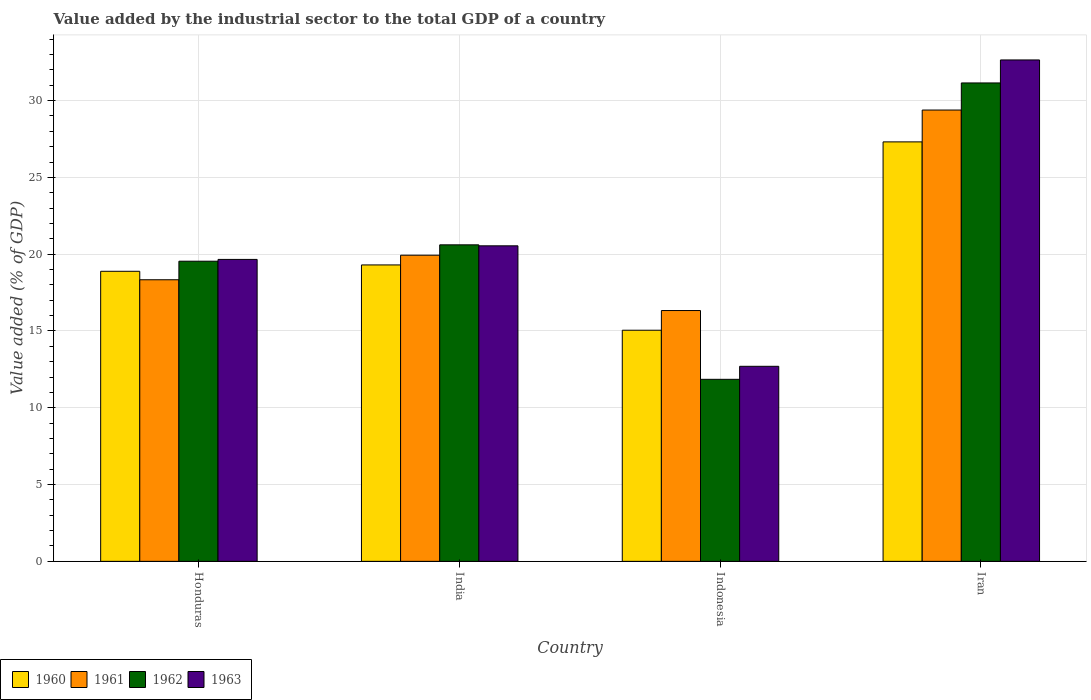Are the number of bars on each tick of the X-axis equal?
Your response must be concise. Yes. How many bars are there on the 1st tick from the right?
Provide a succinct answer. 4. What is the value added by the industrial sector to the total GDP in 1962 in Honduras?
Your answer should be very brief. 19.54. Across all countries, what is the maximum value added by the industrial sector to the total GDP in 1960?
Give a very brief answer. 27.31. Across all countries, what is the minimum value added by the industrial sector to the total GDP in 1963?
Provide a succinct answer. 12.7. In which country was the value added by the industrial sector to the total GDP in 1961 maximum?
Your answer should be very brief. Iran. What is the total value added by the industrial sector to the total GDP in 1962 in the graph?
Your response must be concise. 83.15. What is the difference between the value added by the industrial sector to the total GDP in 1960 in Honduras and that in Indonesia?
Offer a terse response. 3.84. What is the difference between the value added by the industrial sector to the total GDP in 1961 in Iran and the value added by the industrial sector to the total GDP in 1963 in Indonesia?
Keep it short and to the point. 16.69. What is the average value added by the industrial sector to the total GDP in 1960 per country?
Your answer should be very brief. 20.14. What is the difference between the value added by the industrial sector to the total GDP of/in 1962 and value added by the industrial sector to the total GDP of/in 1960 in Iran?
Your response must be concise. 3.84. In how many countries, is the value added by the industrial sector to the total GDP in 1961 greater than 33 %?
Make the answer very short. 0. What is the ratio of the value added by the industrial sector to the total GDP in 1961 in Honduras to that in Iran?
Make the answer very short. 0.62. Is the difference between the value added by the industrial sector to the total GDP in 1962 in Honduras and Iran greater than the difference between the value added by the industrial sector to the total GDP in 1960 in Honduras and Iran?
Provide a succinct answer. No. What is the difference between the highest and the second highest value added by the industrial sector to the total GDP in 1960?
Provide a short and direct response. 0.41. What is the difference between the highest and the lowest value added by the industrial sector to the total GDP in 1963?
Offer a terse response. 19.95. In how many countries, is the value added by the industrial sector to the total GDP in 1963 greater than the average value added by the industrial sector to the total GDP in 1963 taken over all countries?
Provide a succinct answer. 1. What does the 3rd bar from the left in Iran represents?
Offer a very short reply. 1962. What does the 3rd bar from the right in Indonesia represents?
Offer a terse response. 1961. Is it the case that in every country, the sum of the value added by the industrial sector to the total GDP in 1962 and value added by the industrial sector to the total GDP in 1960 is greater than the value added by the industrial sector to the total GDP in 1961?
Your response must be concise. Yes. How many bars are there?
Keep it short and to the point. 16. Are all the bars in the graph horizontal?
Provide a succinct answer. No. What is the difference between two consecutive major ticks on the Y-axis?
Give a very brief answer. 5. Does the graph contain any zero values?
Offer a terse response. No. Where does the legend appear in the graph?
Your answer should be compact. Bottom left. How many legend labels are there?
Make the answer very short. 4. What is the title of the graph?
Give a very brief answer. Value added by the industrial sector to the total GDP of a country. Does "1990" appear as one of the legend labels in the graph?
Provide a short and direct response. No. What is the label or title of the X-axis?
Your answer should be very brief. Country. What is the label or title of the Y-axis?
Your response must be concise. Value added (% of GDP). What is the Value added (% of GDP) of 1960 in Honduras?
Keep it short and to the point. 18.89. What is the Value added (% of GDP) in 1961 in Honduras?
Offer a very short reply. 18.33. What is the Value added (% of GDP) in 1962 in Honduras?
Your answer should be compact. 19.54. What is the Value added (% of GDP) in 1963 in Honduras?
Offer a very short reply. 19.66. What is the Value added (% of GDP) in 1960 in India?
Keep it short and to the point. 19.3. What is the Value added (% of GDP) of 1961 in India?
Provide a succinct answer. 19.93. What is the Value added (% of GDP) in 1962 in India?
Offer a very short reply. 20.61. What is the Value added (% of GDP) in 1963 in India?
Provide a short and direct response. 20.54. What is the Value added (% of GDP) in 1960 in Indonesia?
Give a very brief answer. 15.05. What is the Value added (% of GDP) of 1961 in Indonesia?
Provide a succinct answer. 16.33. What is the Value added (% of GDP) in 1962 in Indonesia?
Offer a terse response. 11.85. What is the Value added (% of GDP) of 1963 in Indonesia?
Offer a very short reply. 12.7. What is the Value added (% of GDP) of 1960 in Iran?
Provide a short and direct response. 27.31. What is the Value added (% of GDP) of 1961 in Iran?
Your response must be concise. 29.38. What is the Value added (% of GDP) of 1962 in Iran?
Keep it short and to the point. 31.15. What is the Value added (% of GDP) of 1963 in Iran?
Keep it short and to the point. 32.65. Across all countries, what is the maximum Value added (% of GDP) in 1960?
Offer a terse response. 27.31. Across all countries, what is the maximum Value added (% of GDP) of 1961?
Your answer should be compact. 29.38. Across all countries, what is the maximum Value added (% of GDP) of 1962?
Your answer should be very brief. 31.15. Across all countries, what is the maximum Value added (% of GDP) of 1963?
Your answer should be very brief. 32.65. Across all countries, what is the minimum Value added (% of GDP) of 1960?
Provide a short and direct response. 15.05. Across all countries, what is the minimum Value added (% of GDP) of 1961?
Provide a short and direct response. 16.33. Across all countries, what is the minimum Value added (% of GDP) of 1962?
Offer a very short reply. 11.85. Across all countries, what is the minimum Value added (% of GDP) of 1963?
Your answer should be very brief. 12.7. What is the total Value added (% of GDP) in 1960 in the graph?
Your answer should be very brief. 80.55. What is the total Value added (% of GDP) in 1961 in the graph?
Ensure brevity in your answer.  83.98. What is the total Value added (% of GDP) in 1962 in the graph?
Give a very brief answer. 83.15. What is the total Value added (% of GDP) in 1963 in the graph?
Your answer should be compact. 85.55. What is the difference between the Value added (% of GDP) of 1960 in Honduras and that in India?
Your answer should be very brief. -0.41. What is the difference between the Value added (% of GDP) in 1961 in Honduras and that in India?
Your answer should be very brief. -1.6. What is the difference between the Value added (% of GDP) of 1962 in Honduras and that in India?
Your answer should be compact. -1.07. What is the difference between the Value added (% of GDP) in 1963 in Honduras and that in India?
Give a very brief answer. -0.88. What is the difference between the Value added (% of GDP) in 1960 in Honduras and that in Indonesia?
Ensure brevity in your answer.  3.84. What is the difference between the Value added (% of GDP) in 1961 in Honduras and that in Indonesia?
Make the answer very short. 2. What is the difference between the Value added (% of GDP) of 1962 in Honduras and that in Indonesia?
Make the answer very short. 7.69. What is the difference between the Value added (% of GDP) of 1963 in Honduras and that in Indonesia?
Provide a short and direct response. 6.96. What is the difference between the Value added (% of GDP) of 1960 in Honduras and that in Iran?
Give a very brief answer. -8.43. What is the difference between the Value added (% of GDP) of 1961 in Honduras and that in Iran?
Keep it short and to the point. -11.05. What is the difference between the Value added (% of GDP) of 1962 in Honduras and that in Iran?
Your response must be concise. -11.61. What is the difference between the Value added (% of GDP) of 1963 in Honduras and that in Iran?
Give a very brief answer. -12.99. What is the difference between the Value added (% of GDP) of 1960 in India and that in Indonesia?
Your answer should be compact. 4.25. What is the difference between the Value added (% of GDP) in 1961 in India and that in Indonesia?
Your answer should be very brief. 3.6. What is the difference between the Value added (% of GDP) in 1962 in India and that in Indonesia?
Offer a terse response. 8.76. What is the difference between the Value added (% of GDP) of 1963 in India and that in Indonesia?
Your response must be concise. 7.84. What is the difference between the Value added (% of GDP) of 1960 in India and that in Iran?
Your response must be concise. -8.01. What is the difference between the Value added (% of GDP) of 1961 in India and that in Iran?
Your response must be concise. -9.45. What is the difference between the Value added (% of GDP) of 1962 in India and that in Iran?
Offer a terse response. -10.54. What is the difference between the Value added (% of GDP) of 1963 in India and that in Iran?
Your response must be concise. -12.1. What is the difference between the Value added (% of GDP) of 1960 in Indonesia and that in Iran?
Make the answer very short. -12.26. What is the difference between the Value added (% of GDP) in 1961 in Indonesia and that in Iran?
Provide a short and direct response. -13.05. What is the difference between the Value added (% of GDP) in 1962 in Indonesia and that in Iran?
Your answer should be very brief. -19.3. What is the difference between the Value added (% of GDP) in 1963 in Indonesia and that in Iran?
Your response must be concise. -19.95. What is the difference between the Value added (% of GDP) in 1960 in Honduras and the Value added (% of GDP) in 1961 in India?
Offer a terse response. -1.05. What is the difference between the Value added (% of GDP) of 1960 in Honduras and the Value added (% of GDP) of 1962 in India?
Provide a short and direct response. -1.72. What is the difference between the Value added (% of GDP) of 1960 in Honduras and the Value added (% of GDP) of 1963 in India?
Ensure brevity in your answer.  -1.66. What is the difference between the Value added (% of GDP) of 1961 in Honduras and the Value added (% of GDP) of 1962 in India?
Ensure brevity in your answer.  -2.27. What is the difference between the Value added (% of GDP) in 1961 in Honduras and the Value added (% of GDP) in 1963 in India?
Make the answer very short. -2.21. What is the difference between the Value added (% of GDP) of 1962 in Honduras and the Value added (% of GDP) of 1963 in India?
Provide a succinct answer. -1. What is the difference between the Value added (% of GDP) of 1960 in Honduras and the Value added (% of GDP) of 1961 in Indonesia?
Give a very brief answer. 2.56. What is the difference between the Value added (% of GDP) in 1960 in Honduras and the Value added (% of GDP) in 1962 in Indonesia?
Your response must be concise. 7.03. What is the difference between the Value added (% of GDP) of 1960 in Honduras and the Value added (% of GDP) of 1963 in Indonesia?
Provide a succinct answer. 6.19. What is the difference between the Value added (% of GDP) of 1961 in Honduras and the Value added (% of GDP) of 1962 in Indonesia?
Provide a short and direct response. 6.48. What is the difference between the Value added (% of GDP) in 1961 in Honduras and the Value added (% of GDP) in 1963 in Indonesia?
Offer a terse response. 5.64. What is the difference between the Value added (% of GDP) in 1962 in Honduras and the Value added (% of GDP) in 1963 in Indonesia?
Ensure brevity in your answer.  6.84. What is the difference between the Value added (% of GDP) in 1960 in Honduras and the Value added (% of GDP) in 1961 in Iran?
Make the answer very short. -10.5. What is the difference between the Value added (% of GDP) of 1960 in Honduras and the Value added (% of GDP) of 1962 in Iran?
Your response must be concise. -12.26. What is the difference between the Value added (% of GDP) in 1960 in Honduras and the Value added (% of GDP) in 1963 in Iran?
Your response must be concise. -13.76. What is the difference between the Value added (% of GDP) in 1961 in Honduras and the Value added (% of GDP) in 1962 in Iran?
Give a very brief answer. -12.81. What is the difference between the Value added (% of GDP) of 1961 in Honduras and the Value added (% of GDP) of 1963 in Iran?
Give a very brief answer. -14.31. What is the difference between the Value added (% of GDP) in 1962 in Honduras and the Value added (% of GDP) in 1963 in Iran?
Your answer should be compact. -13.1. What is the difference between the Value added (% of GDP) in 1960 in India and the Value added (% of GDP) in 1961 in Indonesia?
Your response must be concise. 2.97. What is the difference between the Value added (% of GDP) in 1960 in India and the Value added (% of GDP) in 1962 in Indonesia?
Offer a very short reply. 7.45. What is the difference between the Value added (% of GDP) in 1960 in India and the Value added (% of GDP) in 1963 in Indonesia?
Keep it short and to the point. 6.6. What is the difference between the Value added (% of GDP) in 1961 in India and the Value added (% of GDP) in 1962 in Indonesia?
Your answer should be very brief. 8.08. What is the difference between the Value added (% of GDP) of 1961 in India and the Value added (% of GDP) of 1963 in Indonesia?
Ensure brevity in your answer.  7.23. What is the difference between the Value added (% of GDP) in 1962 in India and the Value added (% of GDP) in 1963 in Indonesia?
Your response must be concise. 7.91. What is the difference between the Value added (% of GDP) of 1960 in India and the Value added (% of GDP) of 1961 in Iran?
Your response must be concise. -10.09. What is the difference between the Value added (% of GDP) of 1960 in India and the Value added (% of GDP) of 1962 in Iran?
Give a very brief answer. -11.85. What is the difference between the Value added (% of GDP) in 1960 in India and the Value added (% of GDP) in 1963 in Iran?
Offer a very short reply. -13.35. What is the difference between the Value added (% of GDP) in 1961 in India and the Value added (% of GDP) in 1962 in Iran?
Your answer should be very brief. -11.22. What is the difference between the Value added (% of GDP) of 1961 in India and the Value added (% of GDP) of 1963 in Iran?
Offer a terse response. -12.71. What is the difference between the Value added (% of GDP) of 1962 in India and the Value added (% of GDP) of 1963 in Iran?
Offer a very short reply. -12.04. What is the difference between the Value added (% of GDP) of 1960 in Indonesia and the Value added (% of GDP) of 1961 in Iran?
Provide a short and direct response. -14.34. What is the difference between the Value added (% of GDP) of 1960 in Indonesia and the Value added (% of GDP) of 1962 in Iran?
Your answer should be very brief. -16.1. What is the difference between the Value added (% of GDP) in 1960 in Indonesia and the Value added (% of GDP) in 1963 in Iran?
Provide a succinct answer. -17.6. What is the difference between the Value added (% of GDP) of 1961 in Indonesia and the Value added (% of GDP) of 1962 in Iran?
Offer a very short reply. -14.82. What is the difference between the Value added (% of GDP) in 1961 in Indonesia and the Value added (% of GDP) in 1963 in Iran?
Your response must be concise. -16.32. What is the difference between the Value added (% of GDP) in 1962 in Indonesia and the Value added (% of GDP) in 1963 in Iran?
Offer a very short reply. -20.79. What is the average Value added (% of GDP) in 1960 per country?
Provide a short and direct response. 20.14. What is the average Value added (% of GDP) of 1961 per country?
Give a very brief answer. 21. What is the average Value added (% of GDP) in 1962 per country?
Make the answer very short. 20.79. What is the average Value added (% of GDP) of 1963 per country?
Your answer should be compact. 21.39. What is the difference between the Value added (% of GDP) of 1960 and Value added (% of GDP) of 1961 in Honduras?
Make the answer very short. 0.55. What is the difference between the Value added (% of GDP) of 1960 and Value added (% of GDP) of 1962 in Honduras?
Your answer should be compact. -0.66. What is the difference between the Value added (% of GDP) of 1960 and Value added (% of GDP) of 1963 in Honduras?
Your response must be concise. -0.77. What is the difference between the Value added (% of GDP) in 1961 and Value added (% of GDP) in 1962 in Honduras?
Your response must be concise. -1.21. What is the difference between the Value added (% of GDP) in 1961 and Value added (% of GDP) in 1963 in Honduras?
Offer a terse response. -1.32. What is the difference between the Value added (% of GDP) of 1962 and Value added (% of GDP) of 1963 in Honduras?
Your answer should be very brief. -0.12. What is the difference between the Value added (% of GDP) of 1960 and Value added (% of GDP) of 1961 in India?
Your response must be concise. -0.63. What is the difference between the Value added (% of GDP) in 1960 and Value added (% of GDP) in 1962 in India?
Provide a short and direct response. -1.31. What is the difference between the Value added (% of GDP) in 1960 and Value added (% of GDP) in 1963 in India?
Your response must be concise. -1.24. What is the difference between the Value added (% of GDP) in 1961 and Value added (% of GDP) in 1962 in India?
Your answer should be very brief. -0.68. What is the difference between the Value added (% of GDP) in 1961 and Value added (% of GDP) in 1963 in India?
Make the answer very short. -0.61. What is the difference between the Value added (% of GDP) of 1962 and Value added (% of GDP) of 1963 in India?
Make the answer very short. 0.06. What is the difference between the Value added (% of GDP) in 1960 and Value added (% of GDP) in 1961 in Indonesia?
Ensure brevity in your answer.  -1.28. What is the difference between the Value added (% of GDP) of 1960 and Value added (% of GDP) of 1962 in Indonesia?
Your answer should be very brief. 3.2. What is the difference between the Value added (% of GDP) of 1960 and Value added (% of GDP) of 1963 in Indonesia?
Your response must be concise. 2.35. What is the difference between the Value added (% of GDP) of 1961 and Value added (% of GDP) of 1962 in Indonesia?
Ensure brevity in your answer.  4.48. What is the difference between the Value added (% of GDP) of 1961 and Value added (% of GDP) of 1963 in Indonesia?
Provide a succinct answer. 3.63. What is the difference between the Value added (% of GDP) of 1962 and Value added (% of GDP) of 1963 in Indonesia?
Your answer should be compact. -0.85. What is the difference between the Value added (% of GDP) of 1960 and Value added (% of GDP) of 1961 in Iran?
Ensure brevity in your answer.  -2.07. What is the difference between the Value added (% of GDP) of 1960 and Value added (% of GDP) of 1962 in Iran?
Offer a very short reply. -3.84. What is the difference between the Value added (% of GDP) in 1960 and Value added (% of GDP) in 1963 in Iran?
Ensure brevity in your answer.  -5.33. What is the difference between the Value added (% of GDP) in 1961 and Value added (% of GDP) in 1962 in Iran?
Your answer should be compact. -1.76. What is the difference between the Value added (% of GDP) in 1961 and Value added (% of GDP) in 1963 in Iran?
Give a very brief answer. -3.26. What is the difference between the Value added (% of GDP) of 1962 and Value added (% of GDP) of 1963 in Iran?
Offer a terse response. -1.5. What is the ratio of the Value added (% of GDP) of 1960 in Honduras to that in India?
Keep it short and to the point. 0.98. What is the ratio of the Value added (% of GDP) of 1961 in Honduras to that in India?
Keep it short and to the point. 0.92. What is the ratio of the Value added (% of GDP) in 1962 in Honduras to that in India?
Provide a short and direct response. 0.95. What is the ratio of the Value added (% of GDP) in 1963 in Honduras to that in India?
Provide a short and direct response. 0.96. What is the ratio of the Value added (% of GDP) of 1960 in Honduras to that in Indonesia?
Ensure brevity in your answer.  1.25. What is the ratio of the Value added (% of GDP) of 1961 in Honduras to that in Indonesia?
Give a very brief answer. 1.12. What is the ratio of the Value added (% of GDP) of 1962 in Honduras to that in Indonesia?
Give a very brief answer. 1.65. What is the ratio of the Value added (% of GDP) in 1963 in Honduras to that in Indonesia?
Provide a short and direct response. 1.55. What is the ratio of the Value added (% of GDP) of 1960 in Honduras to that in Iran?
Your response must be concise. 0.69. What is the ratio of the Value added (% of GDP) of 1961 in Honduras to that in Iran?
Offer a terse response. 0.62. What is the ratio of the Value added (% of GDP) in 1962 in Honduras to that in Iran?
Keep it short and to the point. 0.63. What is the ratio of the Value added (% of GDP) in 1963 in Honduras to that in Iran?
Your answer should be compact. 0.6. What is the ratio of the Value added (% of GDP) of 1960 in India to that in Indonesia?
Provide a succinct answer. 1.28. What is the ratio of the Value added (% of GDP) of 1961 in India to that in Indonesia?
Provide a short and direct response. 1.22. What is the ratio of the Value added (% of GDP) of 1962 in India to that in Indonesia?
Your answer should be very brief. 1.74. What is the ratio of the Value added (% of GDP) in 1963 in India to that in Indonesia?
Ensure brevity in your answer.  1.62. What is the ratio of the Value added (% of GDP) in 1960 in India to that in Iran?
Offer a terse response. 0.71. What is the ratio of the Value added (% of GDP) of 1961 in India to that in Iran?
Make the answer very short. 0.68. What is the ratio of the Value added (% of GDP) of 1962 in India to that in Iran?
Your answer should be compact. 0.66. What is the ratio of the Value added (% of GDP) of 1963 in India to that in Iran?
Make the answer very short. 0.63. What is the ratio of the Value added (% of GDP) in 1960 in Indonesia to that in Iran?
Ensure brevity in your answer.  0.55. What is the ratio of the Value added (% of GDP) of 1961 in Indonesia to that in Iran?
Give a very brief answer. 0.56. What is the ratio of the Value added (% of GDP) in 1962 in Indonesia to that in Iran?
Make the answer very short. 0.38. What is the ratio of the Value added (% of GDP) of 1963 in Indonesia to that in Iran?
Your answer should be very brief. 0.39. What is the difference between the highest and the second highest Value added (% of GDP) in 1960?
Provide a short and direct response. 8.01. What is the difference between the highest and the second highest Value added (% of GDP) of 1961?
Your answer should be compact. 9.45. What is the difference between the highest and the second highest Value added (% of GDP) in 1962?
Your answer should be very brief. 10.54. What is the difference between the highest and the second highest Value added (% of GDP) of 1963?
Give a very brief answer. 12.1. What is the difference between the highest and the lowest Value added (% of GDP) in 1960?
Your response must be concise. 12.26. What is the difference between the highest and the lowest Value added (% of GDP) of 1961?
Provide a short and direct response. 13.05. What is the difference between the highest and the lowest Value added (% of GDP) in 1962?
Make the answer very short. 19.3. What is the difference between the highest and the lowest Value added (% of GDP) of 1963?
Your answer should be compact. 19.95. 